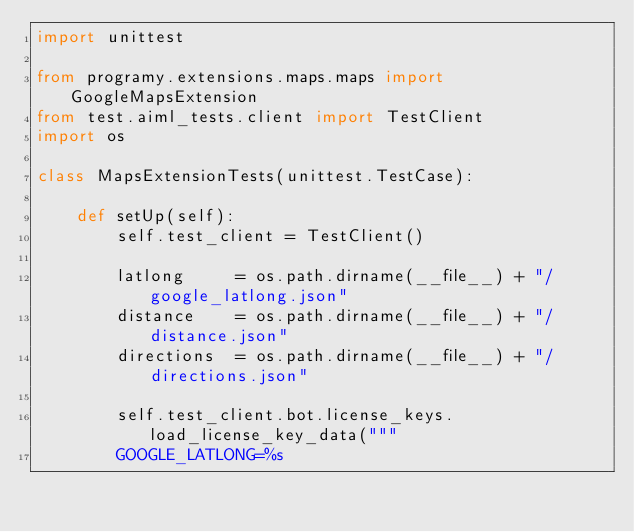Convert code to text. <code><loc_0><loc_0><loc_500><loc_500><_Python_>import unittest

from programy.extensions.maps.maps import GoogleMapsExtension
from test.aiml_tests.client import TestClient
import os

class MapsExtensionTests(unittest.TestCase):

    def setUp(self):
        self.test_client = TestClient()

        latlong     = os.path.dirname(__file__) + "/google_latlong.json"
        distance    = os.path.dirname(__file__) + "/distance.json"
        directions  = os.path.dirname(__file__) + "/directions.json"

        self.test_client.bot.license_keys.load_license_key_data("""
        GOOGLE_LATLONG=%s</code> 